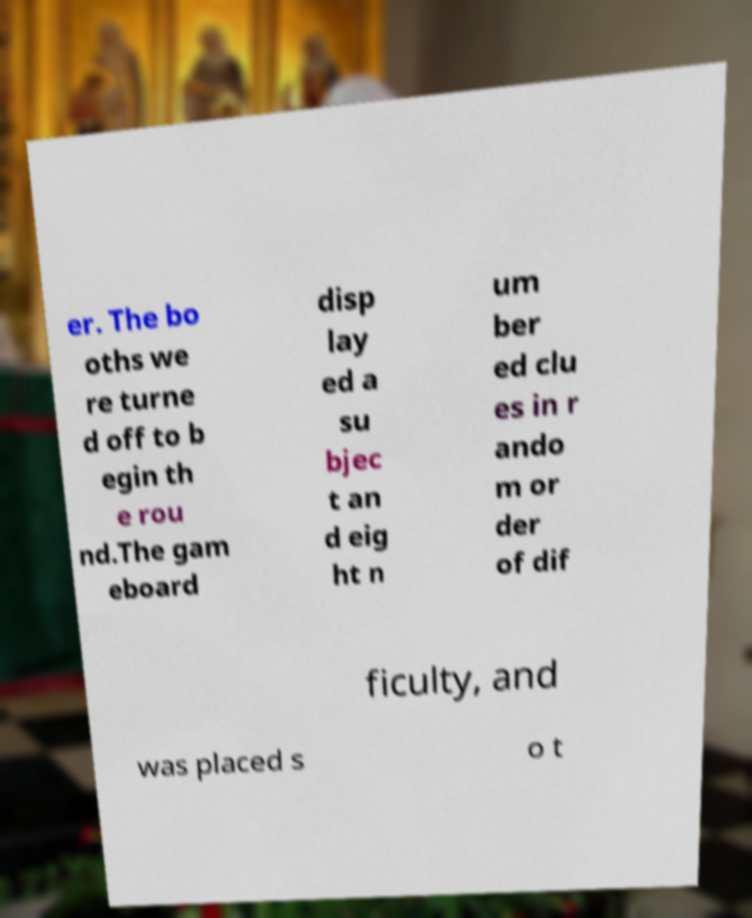I need the written content from this picture converted into text. Can you do that? er. The bo oths we re turne d off to b egin th e rou nd.The gam eboard disp lay ed a su bjec t an d eig ht n um ber ed clu es in r ando m or der of dif ficulty, and was placed s o t 